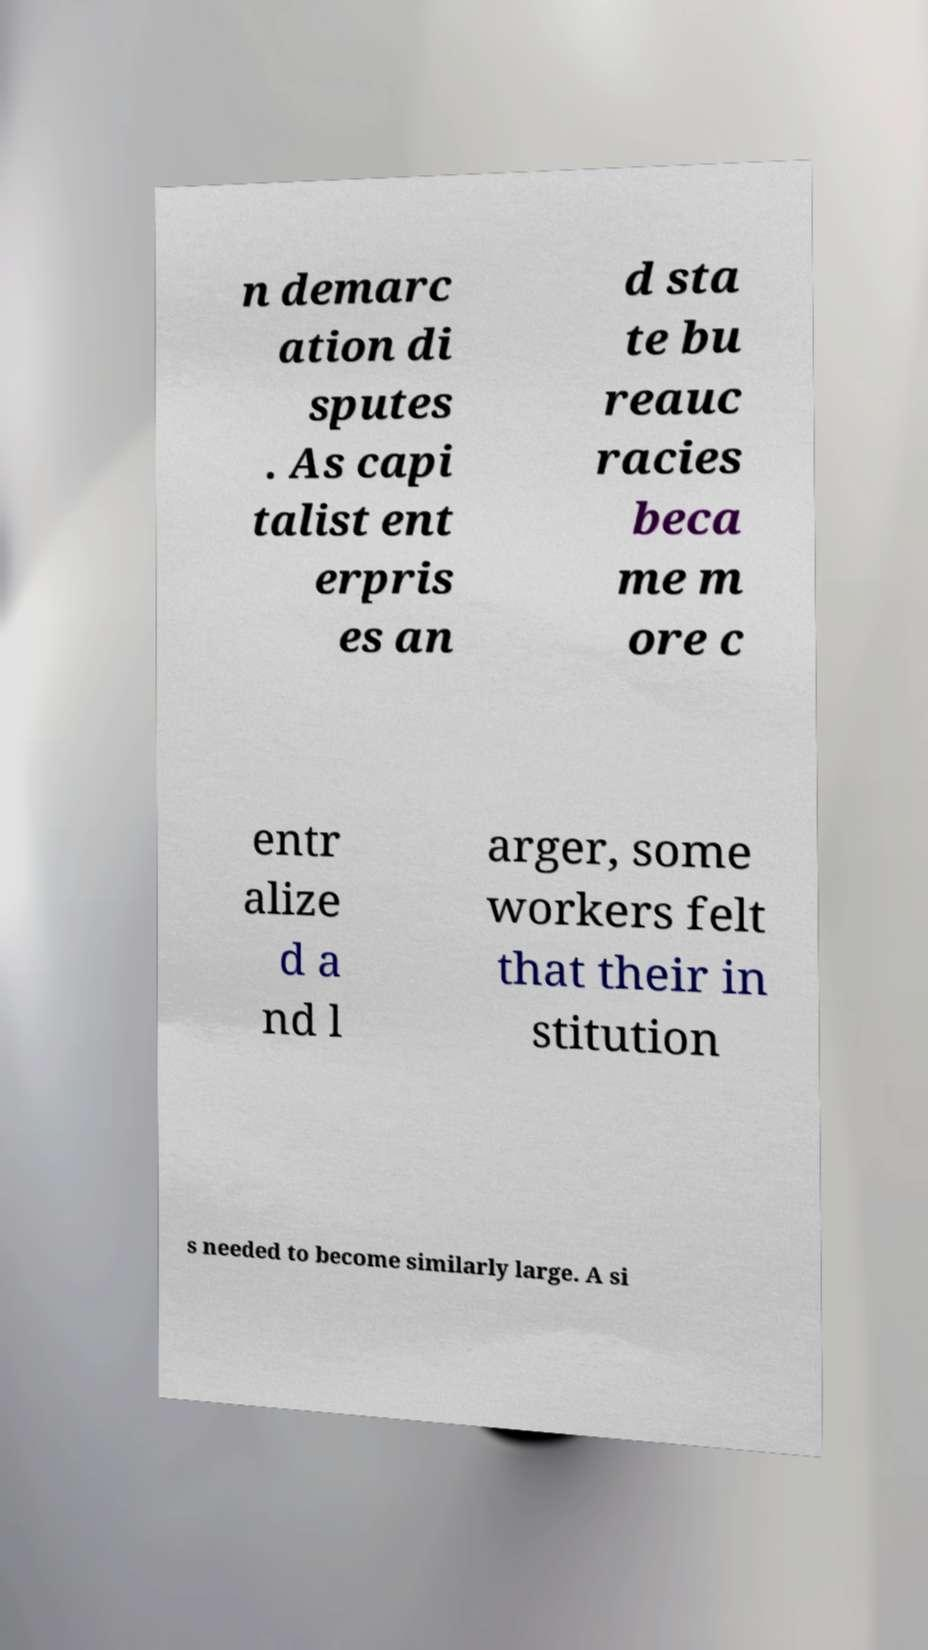There's text embedded in this image that I need extracted. Can you transcribe it verbatim? n demarc ation di sputes . As capi talist ent erpris es an d sta te bu reauc racies beca me m ore c entr alize d a nd l arger, some workers felt that their in stitution s needed to become similarly large. A si 